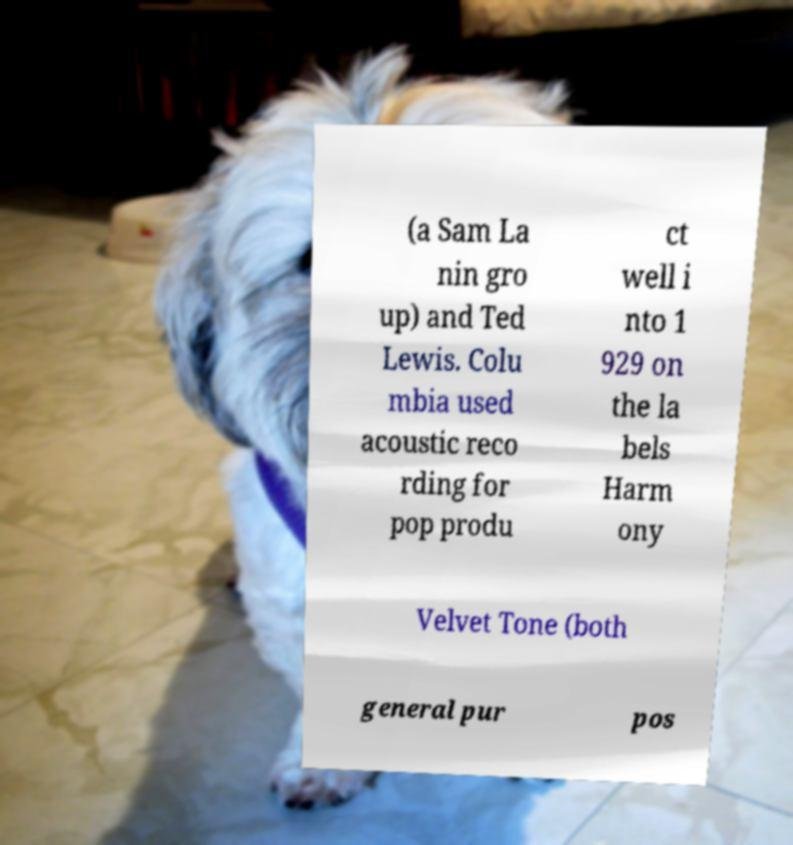There's text embedded in this image that I need extracted. Can you transcribe it verbatim? (a Sam La nin gro up) and Ted Lewis. Colu mbia used acoustic reco rding for pop produ ct well i nto 1 929 on the la bels Harm ony Velvet Tone (both general pur pos 